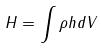<formula> <loc_0><loc_0><loc_500><loc_500>H = \int \rho h d V</formula> 